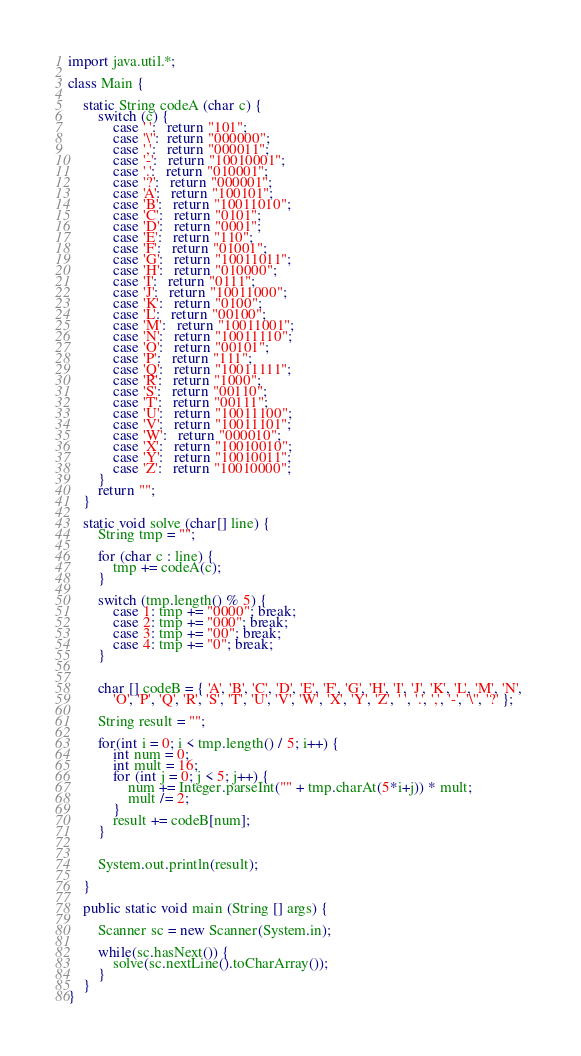<code> <loc_0><loc_0><loc_500><loc_500><_Java_>import java.util.*;

class Main {

    static String codeA (char c) {
        switch (c) {
            case ' ':   return "101";
            case '\'':  return "000000";
            case ',':   return "000011";
            case '-':   return "10010001";
            case '.':   return "010001";
            case '?':   return "000001";
            case 'A':   return "100101";
            case 'B':   return "10011010";
            case 'C':   return "0101";
            case 'D':   return "0001";
            case 'E':   return "110";
            case 'F':   return "01001";
            case 'G':   return "10011011";
            case 'H':   return "010000";
            case 'I':   return "0111";
            case 'J':   return "10011000";
            case 'K':   return "0100";
            case 'L':   return "00100";
            case 'M':   return "10011001";
            case 'N':   return "10011110";
            case 'O':   return "00101";
            case 'P':   return "111";
            case 'Q':   return "10011111";
            case 'R':   return "1000";
            case 'S':   return "00110";
            case 'T':   return "00111";
            case 'U':   return "10011100";
            case 'V':   return "10011101";
            case 'W':   return "000010";
            case 'X':   return "10010010";
            case 'Y':   return "10010011";
            case 'Z':   return "10010000";
        }
        return "";
    }

    static void solve (char[] line) {
        String tmp = "";

        for (char c : line) {
            tmp += codeA(c);    
        }

        switch (tmp.length() % 5) {
            case 1: tmp += "0000"; break;
            case 2: tmp += "000"; break;
            case 3: tmp += "00"; break;
            case 4: tmp += "0"; break;
        }


        char [] codeB = { 'A', 'B', 'C', 'D', 'E', 'F', 'G', 'H', 'I', 'J', 'K', 'L', 'M', 'N', 
            'O', 'P', 'Q', 'R', 'S', 'T', 'U', 'V', 'W', 'X', 'Y', 'Z', ' ', '.', ',', '-', '\'', '?' };

        String result = "";

        for(int i = 0; i < tmp.length() / 5; i++) {
            int num = 0;
            int mult = 16;
            for (int j = 0; j < 5; j++) {
                num += Integer.parseInt("" + tmp.charAt(5*i+j)) * mult;
                mult /= 2;
            }
            result += codeB[num];
        }


        System.out.println(result);
        
    }

    public static void main (String [] args) {

        Scanner sc = new Scanner(System.in);

        while(sc.hasNext()) {
            solve(sc.nextLine().toCharArray());
        }
    }
}</code> 